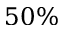<formula> <loc_0><loc_0><loc_500><loc_500>5 0 \%</formula> 